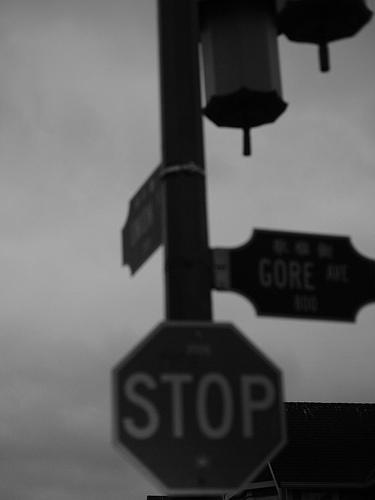How many stop signs are there?
Give a very brief answer. 1. 